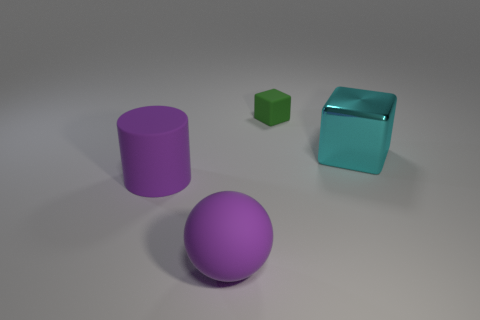Can you describe the texture of the objects? From the image, the objects seem to have varying textures. The purple sphere and cylinder have smooth surfaces that might be pleasant to touch, indicating they could be made of a polished material. The green cube looks like it has a very flat, even texture, while the cyan cube has sleek surfaces that could be slippery due to its reflective quality, suggesting a harder, possibly synthetic material. 